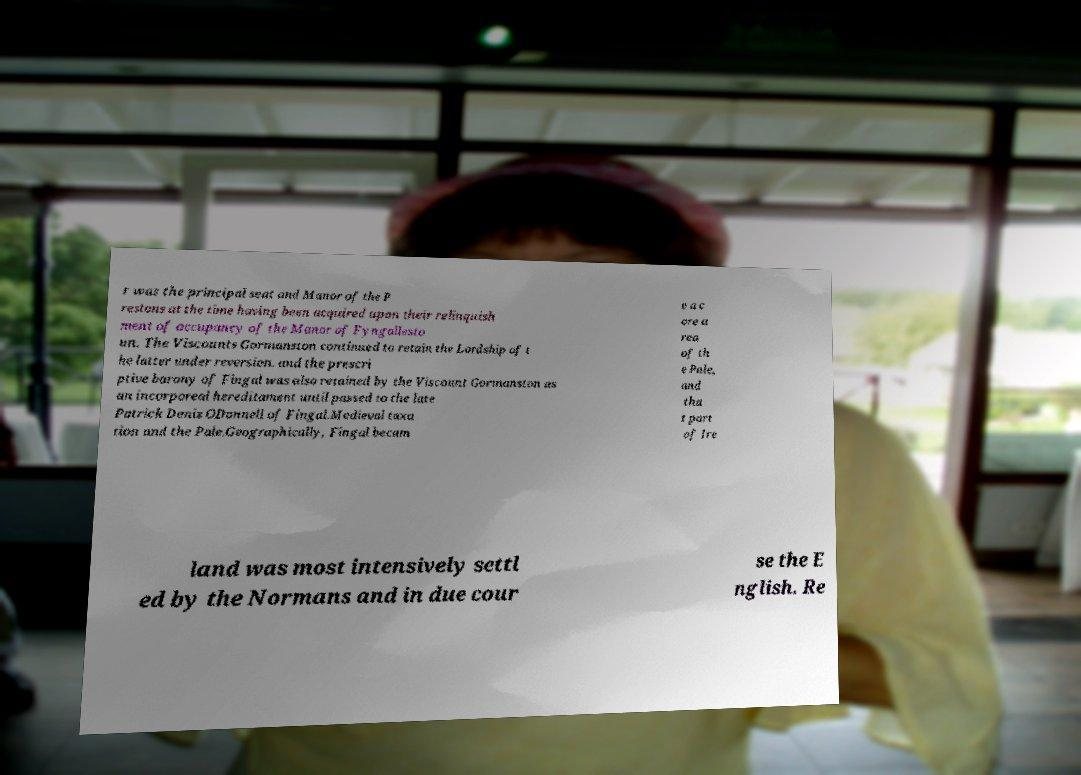For documentation purposes, I need the text within this image transcribed. Could you provide that? r was the principal seat and Manor of the P restons at the time having been acquired upon their relinquish ment of occupancy of the Manor of Fyngallesto un. The Viscounts Gormanston continued to retain the Lordship of t he latter under reversion. and the prescri ptive barony of Fingal was also retained by the Viscount Gormanston as an incorporeal hereditament until passed to the late Patrick Denis ODonnell of Fingal.Medieval taxa tion and the Pale.Geographically, Fingal becam e a c ore a rea of th e Pale, and tha t part of Ire land was most intensively settl ed by the Normans and in due cour se the E nglish. Re 